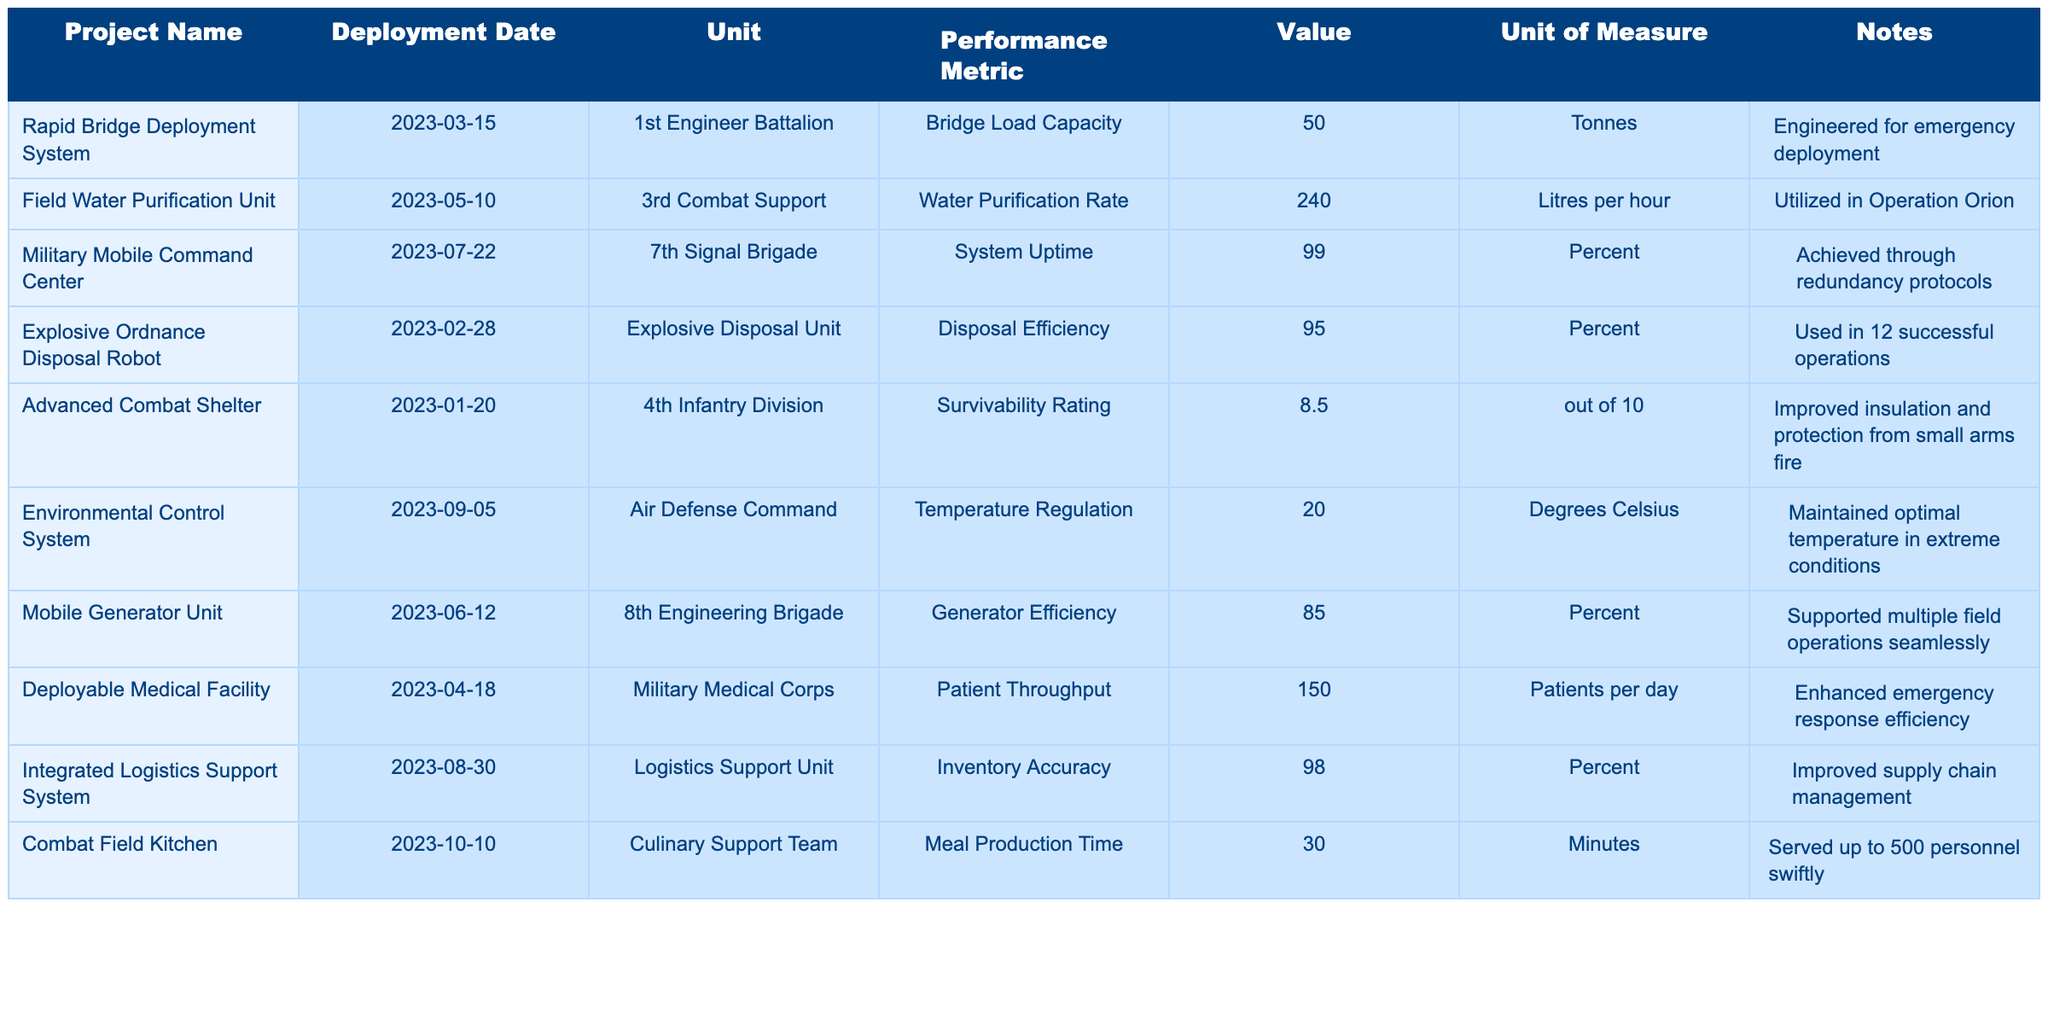What's the value of the Bridge Load Capacity for the Rapid Bridge Deployment System? The table shows that the Bridge Load Capacity for the Rapid Bridge Deployment System is listed as 50 tonnes.
Answer: 50 tonnes Which project has the highest reported System Uptime? The Military Mobile Command Center has a System Uptime of 99 percent, which is the highest value reported in the table.
Answer: 99 percent How many patients can the Deployable Medical Facility handle per day? The Deployable Medical Facility has a Patient Throughput value of 150 patients per day, as indicated in the table.
Answer: 150 patients What is the average Disposal Efficiency of Explosive Ordnance Disposal Robot and Mobile Generator Unit? The Disposal Efficiency for the Explosive Ordnance Disposal Robot is 95 percent and there is no Disposal Efficiency value for the Mobile Generator Unit, so we only consider the robot's value which is 95 percent. Thus, the average is 95/1 = 95 percent.
Answer: 95 percent Is the Meal Production Time for the Combat Field Kitchen less than 40 minutes? The Meal Production Time for the Combat Field Kitchen is 30 minutes, which is indeed less than 40 minutes.
Answer: Yes Which project was deployed first among the engineering solutions listed? The Advanced Combat Shelter was deployed on 2023-01-20, making it the earliest project when compared to the other deployment dates in the table.
Answer: Advanced Combat Shelter What is the total Water Purification Rate of all the projects? The only project with a Water Purification Rate is the Field Water Purification Unit at 240 litres per hour. Hence, the total is just that value: 240 litres per hour.
Answer: 240 litres per hour Which unit has the best Inventory Accuracy among the projects? The Integrated Logistics Support System reports an Inventory Accuracy of 98 percent, making it the unit with the best accuracy in the table.
Answer: 98 percent Calculate the difference in temperature regulation capability between the Environmental Control System and the Advanced Combat Shelter. The Environmental Control System has a Temperature Regulation of 20 degrees Celsius and the Advanced Combat Shelter has a Survivability Rating of 8.5 out of 10, which doesn't pertain to temperature. Thus, the comparison doesn’t apply.
Answer: Not applicable Did the Mobile Generator Unit support multiple field operations seamlessly according to the notes? Yes, the notes for the Mobile Generator Unit indicate that it supported multiple field operations seamlessly.
Answer: Yes What is the highest Survivability Rating among the projects listed? The Advanced Combat Shelter has a Survivability Rating of 8.5 out of 10, which is the highest rating mentioned in the table.
Answer: 8.5 out of 10 